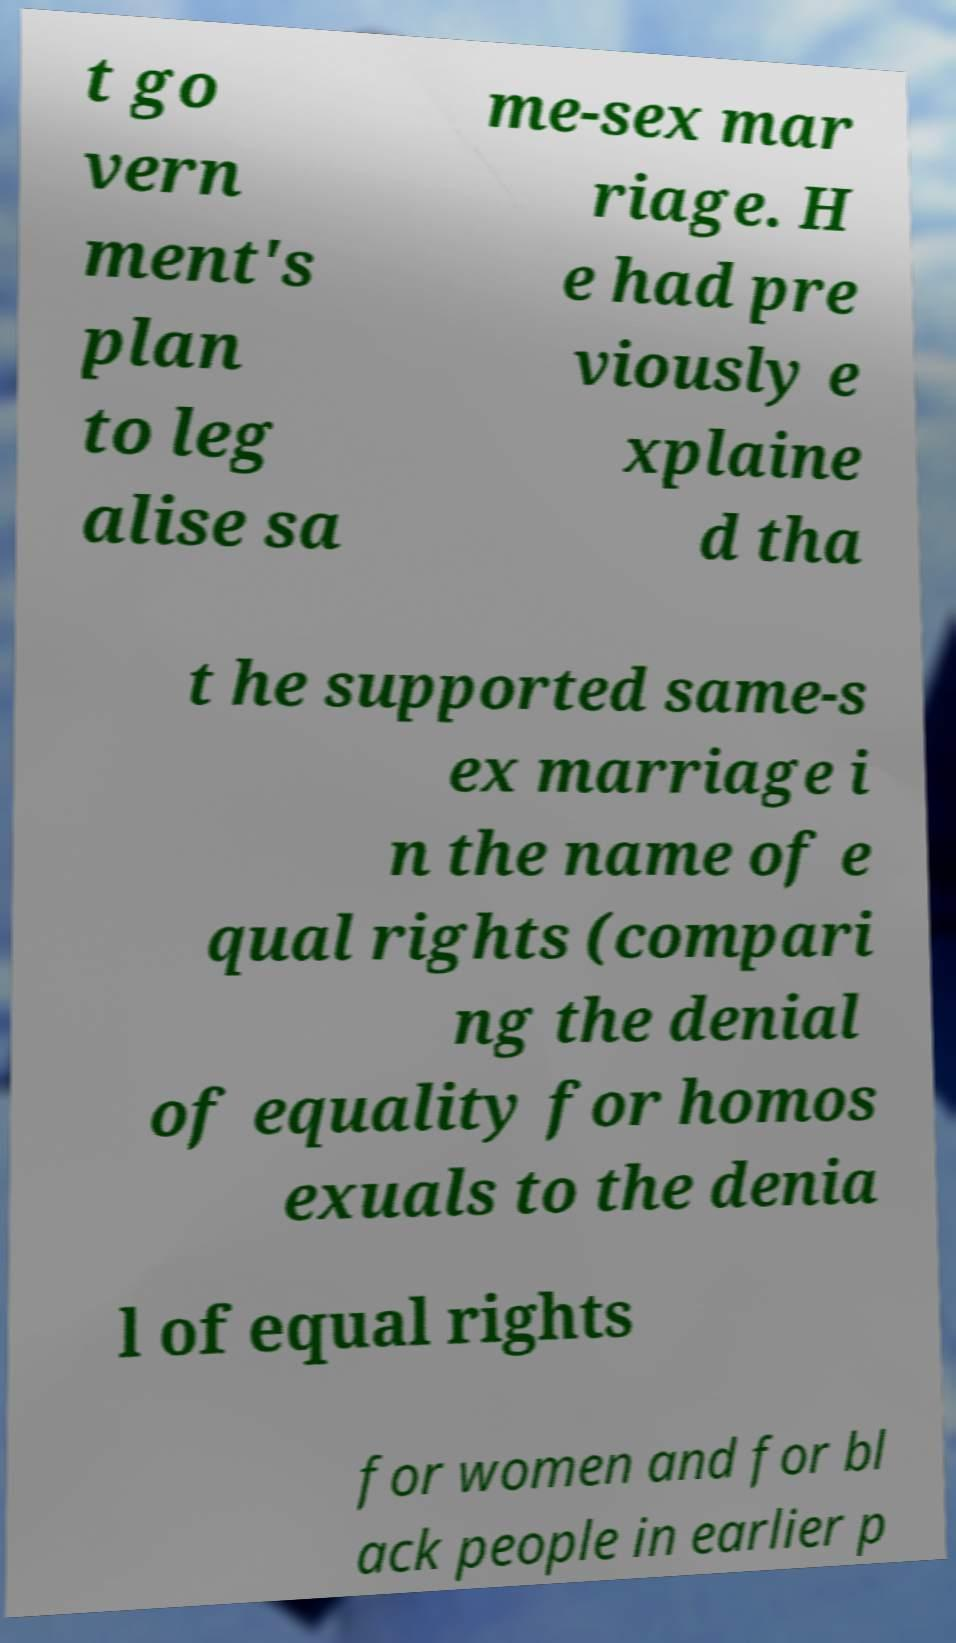Can you read and provide the text displayed in the image?This photo seems to have some interesting text. Can you extract and type it out for me? t go vern ment's plan to leg alise sa me-sex mar riage. H e had pre viously e xplaine d tha t he supported same-s ex marriage i n the name of e qual rights (compari ng the denial of equality for homos exuals to the denia l of equal rights for women and for bl ack people in earlier p 